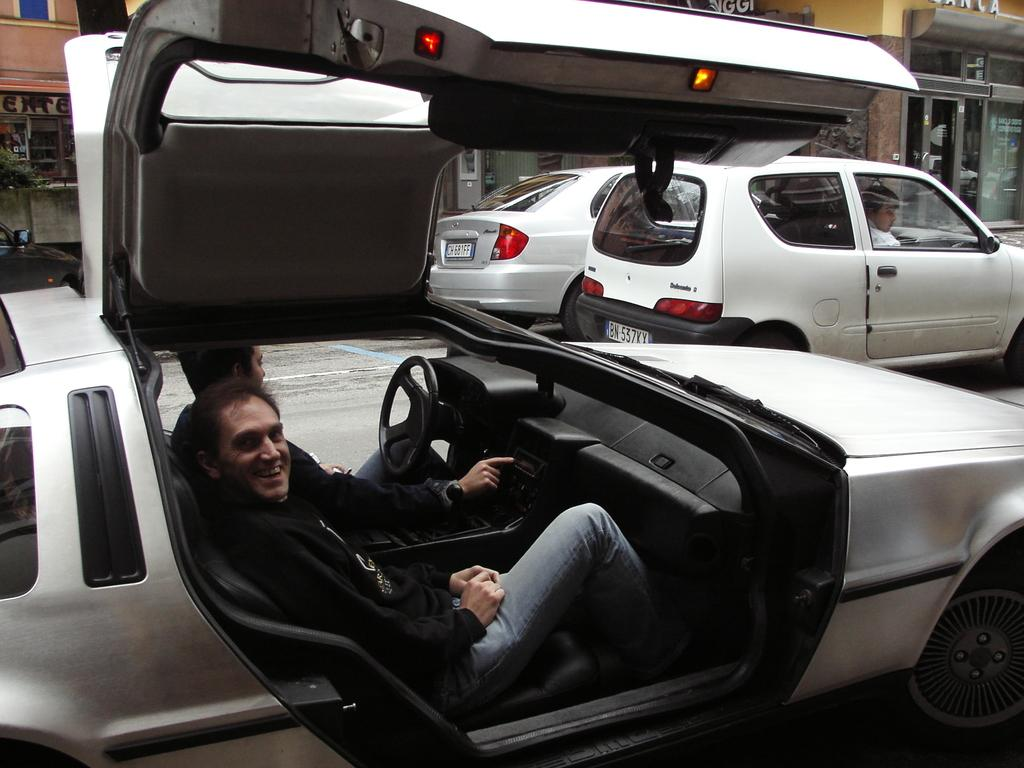What is the main subject in the center of the image? There are cars in the center of the image. What are the people in the cars doing? People are sitting in the cars. What can be seen in the background of the image? There are buildings in the background of the image. What type of silk fabric is draped over the curve of the silver statue in the image? There is no silk fabric, curve, or silver statue present in the image. 